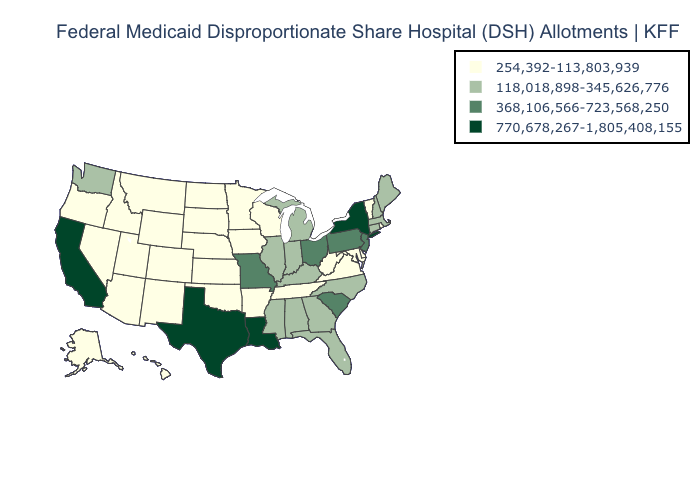What is the value of Kentucky?
Answer briefly. 118,018,898-345,626,776. What is the value of Hawaii?
Answer briefly. 254,392-113,803,939. Does New Jersey have the lowest value in the Northeast?
Short answer required. No. What is the lowest value in the USA?
Short answer required. 254,392-113,803,939. Does Missouri have the same value as Illinois?
Answer briefly. No. Does the map have missing data?
Give a very brief answer. No. Does Georgia have a higher value than Maine?
Short answer required. No. What is the lowest value in the USA?
Be succinct. 254,392-113,803,939. Among the states that border New Mexico , does Colorado have the lowest value?
Answer briefly. Yes. Name the states that have a value in the range 368,106,566-723,568,250?
Short answer required. Missouri, New Jersey, Ohio, Pennsylvania, South Carolina. What is the lowest value in states that border Delaware?
Concise answer only. 254,392-113,803,939. Does California have the highest value in the West?
Write a very short answer. Yes. What is the value of Mississippi?
Quick response, please. 118,018,898-345,626,776. Name the states that have a value in the range 254,392-113,803,939?
Quick response, please. Alaska, Arizona, Arkansas, Colorado, Delaware, Hawaii, Idaho, Iowa, Kansas, Maryland, Minnesota, Montana, Nebraska, Nevada, New Mexico, North Dakota, Oklahoma, Oregon, Rhode Island, South Dakota, Tennessee, Utah, Vermont, Virginia, West Virginia, Wisconsin, Wyoming. Name the states that have a value in the range 118,018,898-345,626,776?
Keep it brief. Alabama, Connecticut, Florida, Georgia, Illinois, Indiana, Kentucky, Maine, Massachusetts, Michigan, Mississippi, New Hampshire, North Carolina, Washington. 